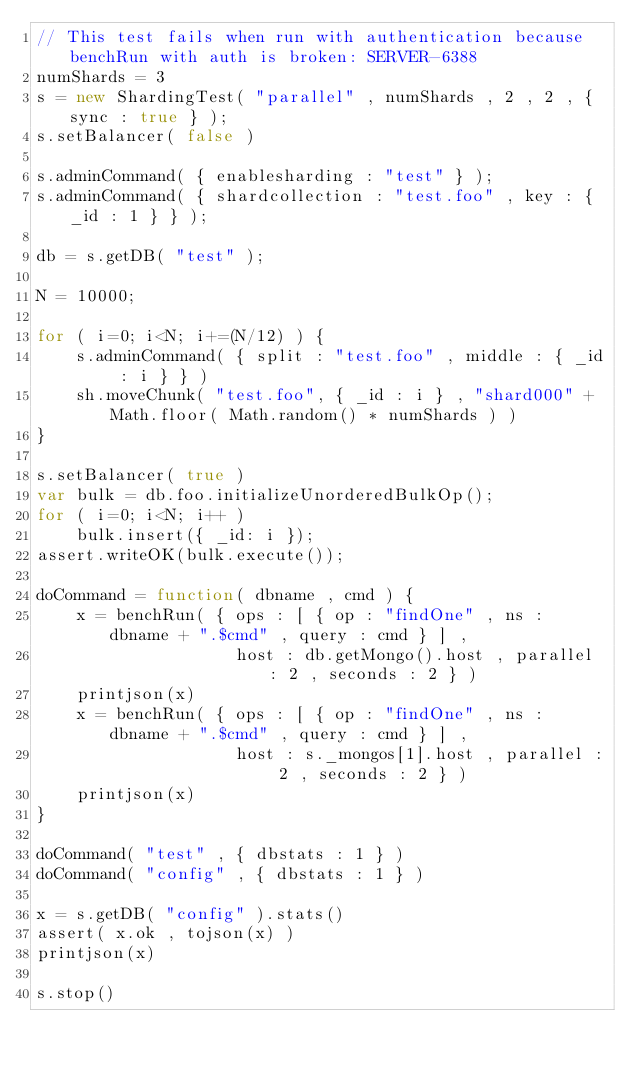Convert code to text. <code><loc_0><loc_0><loc_500><loc_500><_JavaScript_>// This test fails when run with authentication because benchRun with auth is broken: SERVER-6388
numShards = 3
s = new ShardingTest( "parallel" , numShards , 2 , 2 , { sync : true } );
s.setBalancer( false )

s.adminCommand( { enablesharding : "test" } );
s.adminCommand( { shardcollection : "test.foo" , key : { _id : 1 } } ); 

db = s.getDB( "test" );

N = 10000;

for ( i=0; i<N; i+=(N/12) ) {
    s.adminCommand( { split : "test.foo" , middle : { _id : i } } )
    sh.moveChunk( "test.foo", { _id : i } , "shard000" + Math.floor( Math.random() * numShards ) )
}

s.setBalancer( true )
var bulk = db.foo.initializeUnorderedBulkOp();
for ( i=0; i<N; i++ )
    bulk.insert({ _id: i });
assert.writeOK(bulk.execute());

doCommand = function( dbname , cmd ) {
    x = benchRun( { ops : [ { op : "findOne" , ns : dbname + ".$cmd" , query : cmd } ] , 
                    host : db.getMongo().host , parallel : 2 , seconds : 2 } )
    printjson(x)
    x = benchRun( { ops : [ { op : "findOne" , ns : dbname + ".$cmd" , query : cmd } ] , 
                    host : s._mongos[1].host , parallel : 2 , seconds : 2 } )
    printjson(x)
}

doCommand( "test" , { dbstats : 1 } )
doCommand( "config" , { dbstats : 1 } )

x = s.getDB( "config" ).stats()
assert( x.ok , tojson(x) )
printjson(x)

s.stop()
</code> 